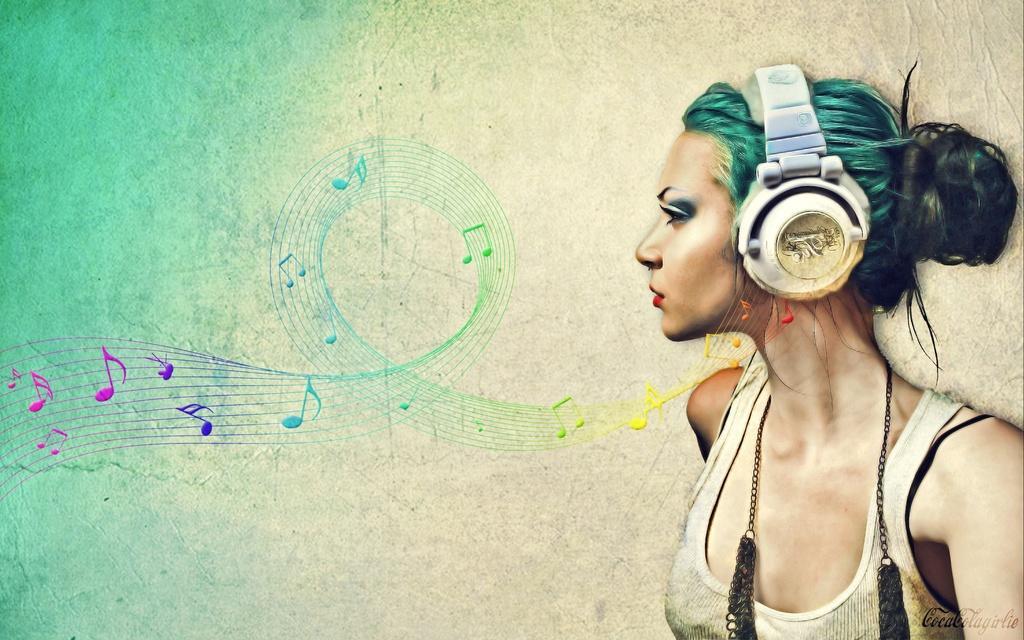Could you give a brief overview of what you see in this image? This is an edited image, in this image, on the right side there is a lady standing, in the background there is a wall and there are some musical notes, on the bottom right there is some text. 